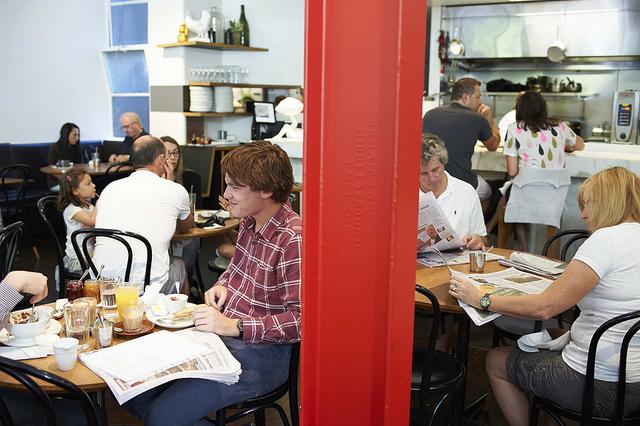How many people are sitting at the counter?
Answer briefly. 2. What color is the pole?
Quick response, please. Red. What place is this?
Keep it brief. Restaurant. 